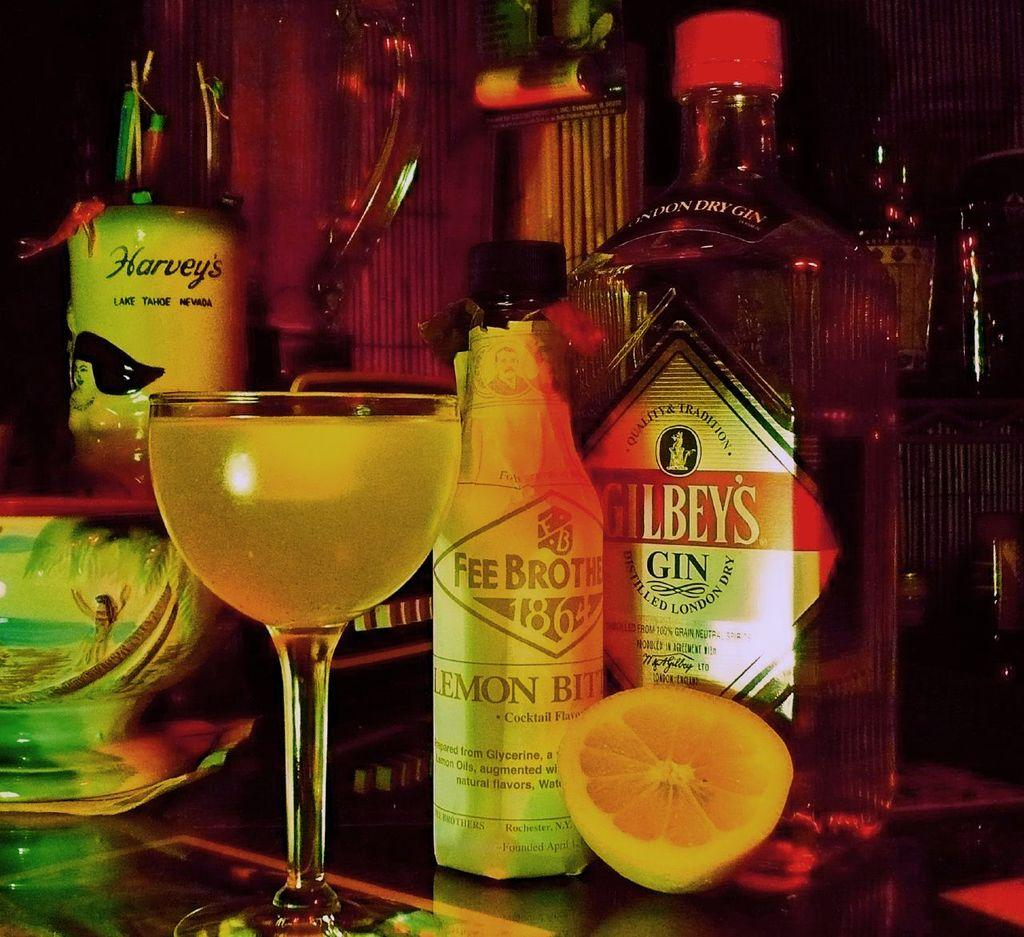What type of drink is in the glass in the image? There is a glass of wine in the image. What other wine-related object is present in the image? There is a wine bottle in the image. What additional item can be seen in the image? There is a lemon piece in the image. On what surface are the objects placed? The objects are placed on a glass table. What type of ink is used to write on the card in the image? There is no card present in the image, so it is not possible to determine the type of ink used. 